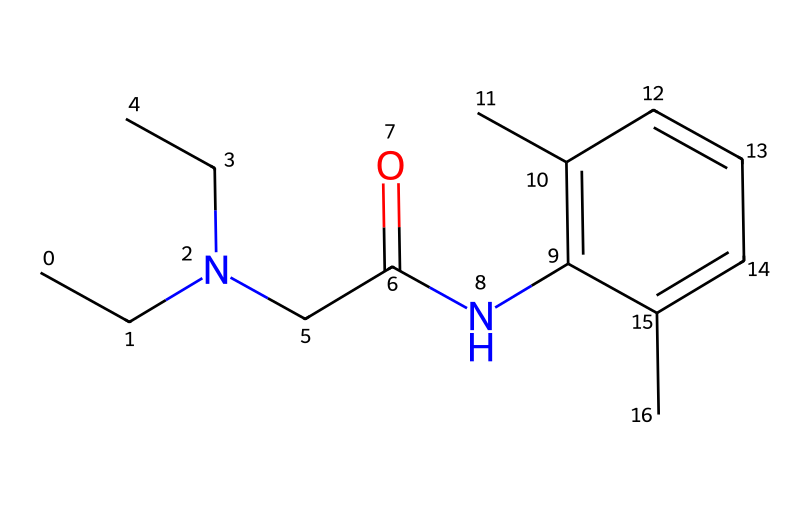What is the molecular formula of lidocaine? The molecular formula can be deduced by counting the number of carbon (C), hydrogen (H), nitrogen (N), and oxygen (O) atoms in the provided SMILES. Counting results in C14H22N2O, which represents the composition of lidocaine.
Answer: C14H22N2O How many nitrogen atoms are in the lidocaine structure? By examining the SMILES representation, we can identify the presence of nitrogen atoms. There are two nitrogen atoms indicated in the structure.
Answer: 2 What type of functional group is present in lidocaine? The presence of the amide functional group (-C(=O)N-) can be identified from the SMILES string between the carbonyl group (C=O) and nitrogen atom, indicating that lidocaine contains an amide group.
Answer: amide Does lidocaine contain any aromatic rings? The presence of the “c” indicates aromatic carbons. In the given structure, there is a benzene ring present due to multiple connected "c" characters, confirming the presence of an aromatic ring.
Answer: yes What is the significance of the acetyl group in lidocaine? The acetyl group (CC(=O)-) is crucial in the structure of lidocaine as it contributes to the overall properties of the compound, including its pharmacological activity as a local anesthetic.
Answer: pharmacological activity What is the total number of rings in the lidocaine structure? Analyzing the SMILES representation, it is noted that there is one aromatic ring present in lidocaine, contributing to its unique properties.
Answer: 1 